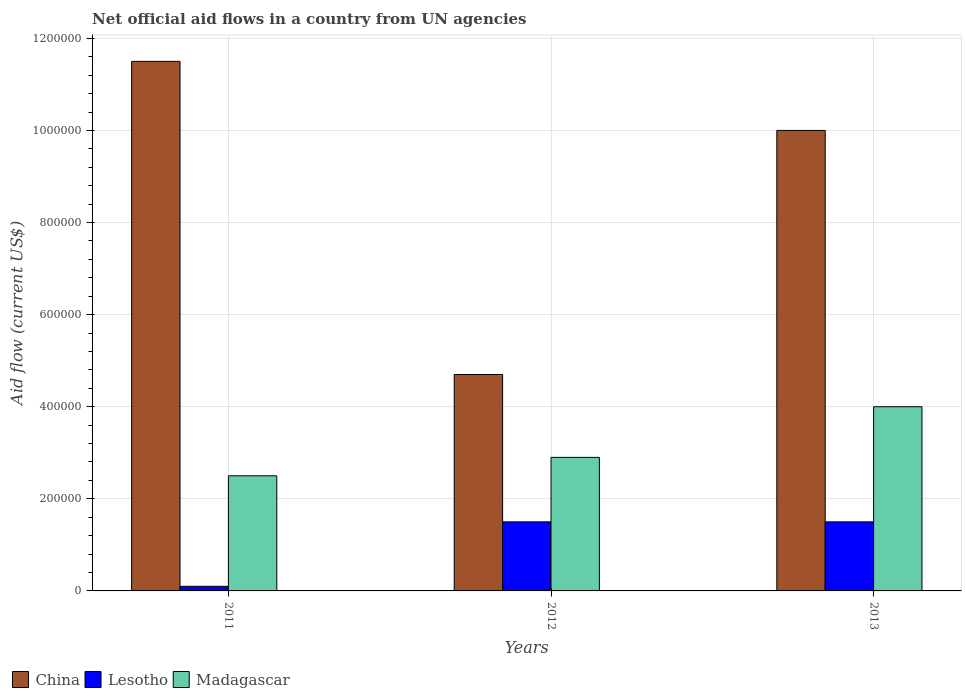Are the number of bars per tick equal to the number of legend labels?
Give a very brief answer. Yes. Are the number of bars on each tick of the X-axis equal?
Offer a very short reply. Yes. In how many cases, is the number of bars for a given year not equal to the number of legend labels?
Make the answer very short. 0. What is the net official aid flow in Madagascar in 2011?
Give a very brief answer. 2.50e+05. Across all years, what is the maximum net official aid flow in China?
Provide a succinct answer. 1.15e+06. Across all years, what is the minimum net official aid flow in Lesotho?
Your answer should be very brief. 10000. In which year was the net official aid flow in Lesotho maximum?
Provide a short and direct response. 2012. In which year was the net official aid flow in Madagascar minimum?
Keep it short and to the point. 2011. What is the total net official aid flow in Madagascar in the graph?
Keep it short and to the point. 9.40e+05. What is the difference between the net official aid flow in Madagascar in 2012 and that in 2013?
Keep it short and to the point. -1.10e+05. What is the difference between the net official aid flow in Lesotho in 2012 and the net official aid flow in Madagascar in 2013?
Your response must be concise. -2.50e+05. What is the average net official aid flow in China per year?
Provide a succinct answer. 8.73e+05. In the year 2013, what is the difference between the net official aid flow in Madagascar and net official aid flow in China?
Give a very brief answer. -6.00e+05. Is the net official aid flow in Lesotho in 2011 less than that in 2013?
Your response must be concise. Yes. Is the difference between the net official aid flow in Madagascar in 2011 and 2012 greater than the difference between the net official aid flow in China in 2011 and 2012?
Make the answer very short. No. What is the difference between the highest and the lowest net official aid flow in China?
Offer a terse response. 6.80e+05. In how many years, is the net official aid flow in Madagascar greater than the average net official aid flow in Madagascar taken over all years?
Make the answer very short. 1. What does the 3rd bar from the left in 2013 represents?
Offer a terse response. Madagascar. Is it the case that in every year, the sum of the net official aid flow in China and net official aid flow in Madagascar is greater than the net official aid flow in Lesotho?
Make the answer very short. Yes. How many bars are there?
Keep it short and to the point. 9. Are all the bars in the graph horizontal?
Your response must be concise. No. How many years are there in the graph?
Keep it short and to the point. 3. What is the difference between two consecutive major ticks on the Y-axis?
Give a very brief answer. 2.00e+05. Are the values on the major ticks of Y-axis written in scientific E-notation?
Provide a succinct answer. No. Does the graph contain any zero values?
Provide a succinct answer. No. Where does the legend appear in the graph?
Keep it short and to the point. Bottom left. How many legend labels are there?
Ensure brevity in your answer.  3. How are the legend labels stacked?
Provide a short and direct response. Horizontal. What is the title of the graph?
Provide a succinct answer. Net official aid flows in a country from UN agencies. Does "Lithuania" appear as one of the legend labels in the graph?
Provide a succinct answer. No. What is the label or title of the X-axis?
Make the answer very short. Years. What is the label or title of the Y-axis?
Ensure brevity in your answer.  Aid flow (current US$). What is the Aid flow (current US$) in China in 2011?
Your response must be concise. 1.15e+06. What is the Aid flow (current US$) of Lesotho in 2011?
Ensure brevity in your answer.  10000. What is the Aid flow (current US$) in Lesotho in 2012?
Provide a short and direct response. 1.50e+05. What is the Aid flow (current US$) in Madagascar in 2012?
Keep it short and to the point. 2.90e+05. What is the Aid flow (current US$) in Lesotho in 2013?
Make the answer very short. 1.50e+05. What is the Aid flow (current US$) of Madagascar in 2013?
Offer a terse response. 4.00e+05. Across all years, what is the maximum Aid flow (current US$) of China?
Give a very brief answer. 1.15e+06. Across all years, what is the maximum Aid flow (current US$) of Lesotho?
Provide a short and direct response. 1.50e+05. What is the total Aid flow (current US$) of China in the graph?
Your response must be concise. 2.62e+06. What is the total Aid flow (current US$) of Lesotho in the graph?
Give a very brief answer. 3.10e+05. What is the total Aid flow (current US$) of Madagascar in the graph?
Keep it short and to the point. 9.40e+05. What is the difference between the Aid flow (current US$) of China in 2011 and that in 2012?
Your answer should be compact. 6.80e+05. What is the difference between the Aid flow (current US$) in Lesotho in 2011 and that in 2012?
Make the answer very short. -1.40e+05. What is the difference between the Aid flow (current US$) of Lesotho in 2011 and that in 2013?
Your answer should be very brief. -1.40e+05. What is the difference between the Aid flow (current US$) in Madagascar in 2011 and that in 2013?
Offer a very short reply. -1.50e+05. What is the difference between the Aid flow (current US$) in China in 2012 and that in 2013?
Give a very brief answer. -5.30e+05. What is the difference between the Aid flow (current US$) of Madagascar in 2012 and that in 2013?
Your answer should be very brief. -1.10e+05. What is the difference between the Aid flow (current US$) in China in 2011 and the Aid flow (current US$) in Madagascar in 2012?
Offer a very short reply. 8.60e+05. What is the difference between the Aid flow (current US$) of Lesotho in 2011 and the Aid flow (current US$) of Madagascar in 2012?
Offer a very short reply. -2.80e+05. What is the difference between the Aid flow (current US$) in China in 2011 and the Aid flow (current US$) in Lesotho in 2013?
Provide a succinct answer. 1.00e+06. What is the difference between the Aid flow (current US$) of China in 2011 and the Aid flow (current US$) of Madagascar in 2013?
Provide a succinct answer. 7.50e+05. What is the difference between the Aid flow (current US$) of Lesotho in 2011 and the Aid flow (current US$) of Madagascar in 2013?
Ensure brevity in your answer.  -3.90e+05. What is the average Aid flow (current US$) in China per year?
Make the answer very short. 8.73e+05. What is the average Aid flow (current US$) of Lesotho per year?
Offer a very short reply. 1.03e+05. What is the average Aid flow (current US$) in Madagascar per year?
Make the answer very short. 3.13e+05. In the year 2011, what is the difference between the Aid flow (current US$) of China and Aid flow (current US$) of Lesotho?
Offer a terse response. 1.14e+06. In the year 2012, what is the difference between the Aid flow (current US$) of China and Aid flow (current US$) of Lesotho?
Make the answer very short. 3.20e+05. In the year 2012, what is the difference between the Aid flow (current US$) in China and Aid flow (current US$) in Madagascar?
Give a very brief answer. 1.80e+05. In the year 2012, what is the difference between the Aid flow (current US$) of Lesotho and Aid flow (current US$) of Madagascar?
Offer a terse response. -1.40e+05. In the year 2013, what is the difference between the Aid flow (current US$) of China and Aid flow (current US$) of Lesotho?
Keep it short and to the point. 8.50e+05. What is the ratio of the Aid flow (current US$) in China in 2011 to that in 2012?
Your response must be concise. 2.45. What is the ratio of the Aid flow (current US$) of Lesotho in 2011 to that in 2012?
Provide a succinct answer. 0.07. What is the ratio of the Aid flow (current US$) of Madagascar in 2011 to that in 2012?
Your answer should be very brief. 0.86. What is the ratio of the Aid flow (current US$) of China in 2011 to that in 2013?
Your answer should be very brief. 1.15. What is the ratio of the Aid flow (current US$) of Lesotho in 2011 to that in 2013?
Keep it short and to the point. 0.07. What is the ratio of the Aid flow (current US$) of China in 2012 to that in 2013?
Keep it short and to the point. 0.47. What is the ratio of the Aid flow (current US$) of Madagascar in 2012 to that in 2013?
Your answer should be very brief. 0.72. What is the difference between the highest and the second highest Aid flow (current US$) in China?
Keep it short and to the point. 1.50e+05. What is the difference between the highest and the lowest Aid flow (current US$) in China?
Ensure brevity in your answer.  6.80e+05. 